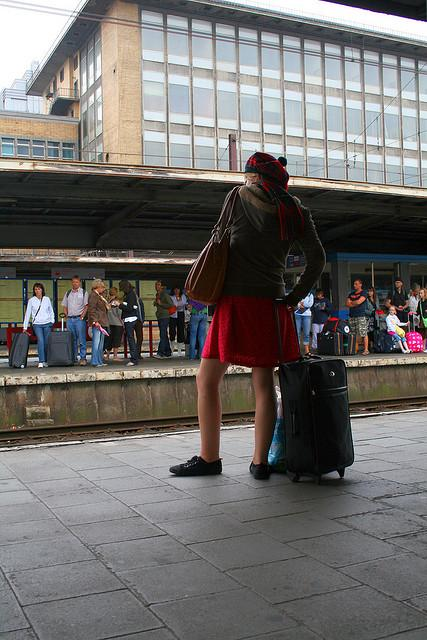What color is the suitcase held by the girl on the other side of the boarding deck to the right of the woman in the foreground?

Choices:
A) red
B) blue
C) pink
D) green pink 